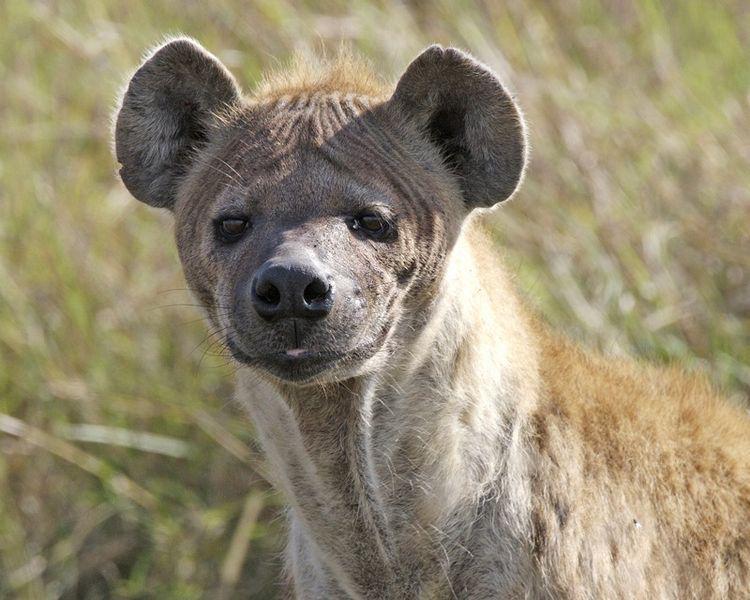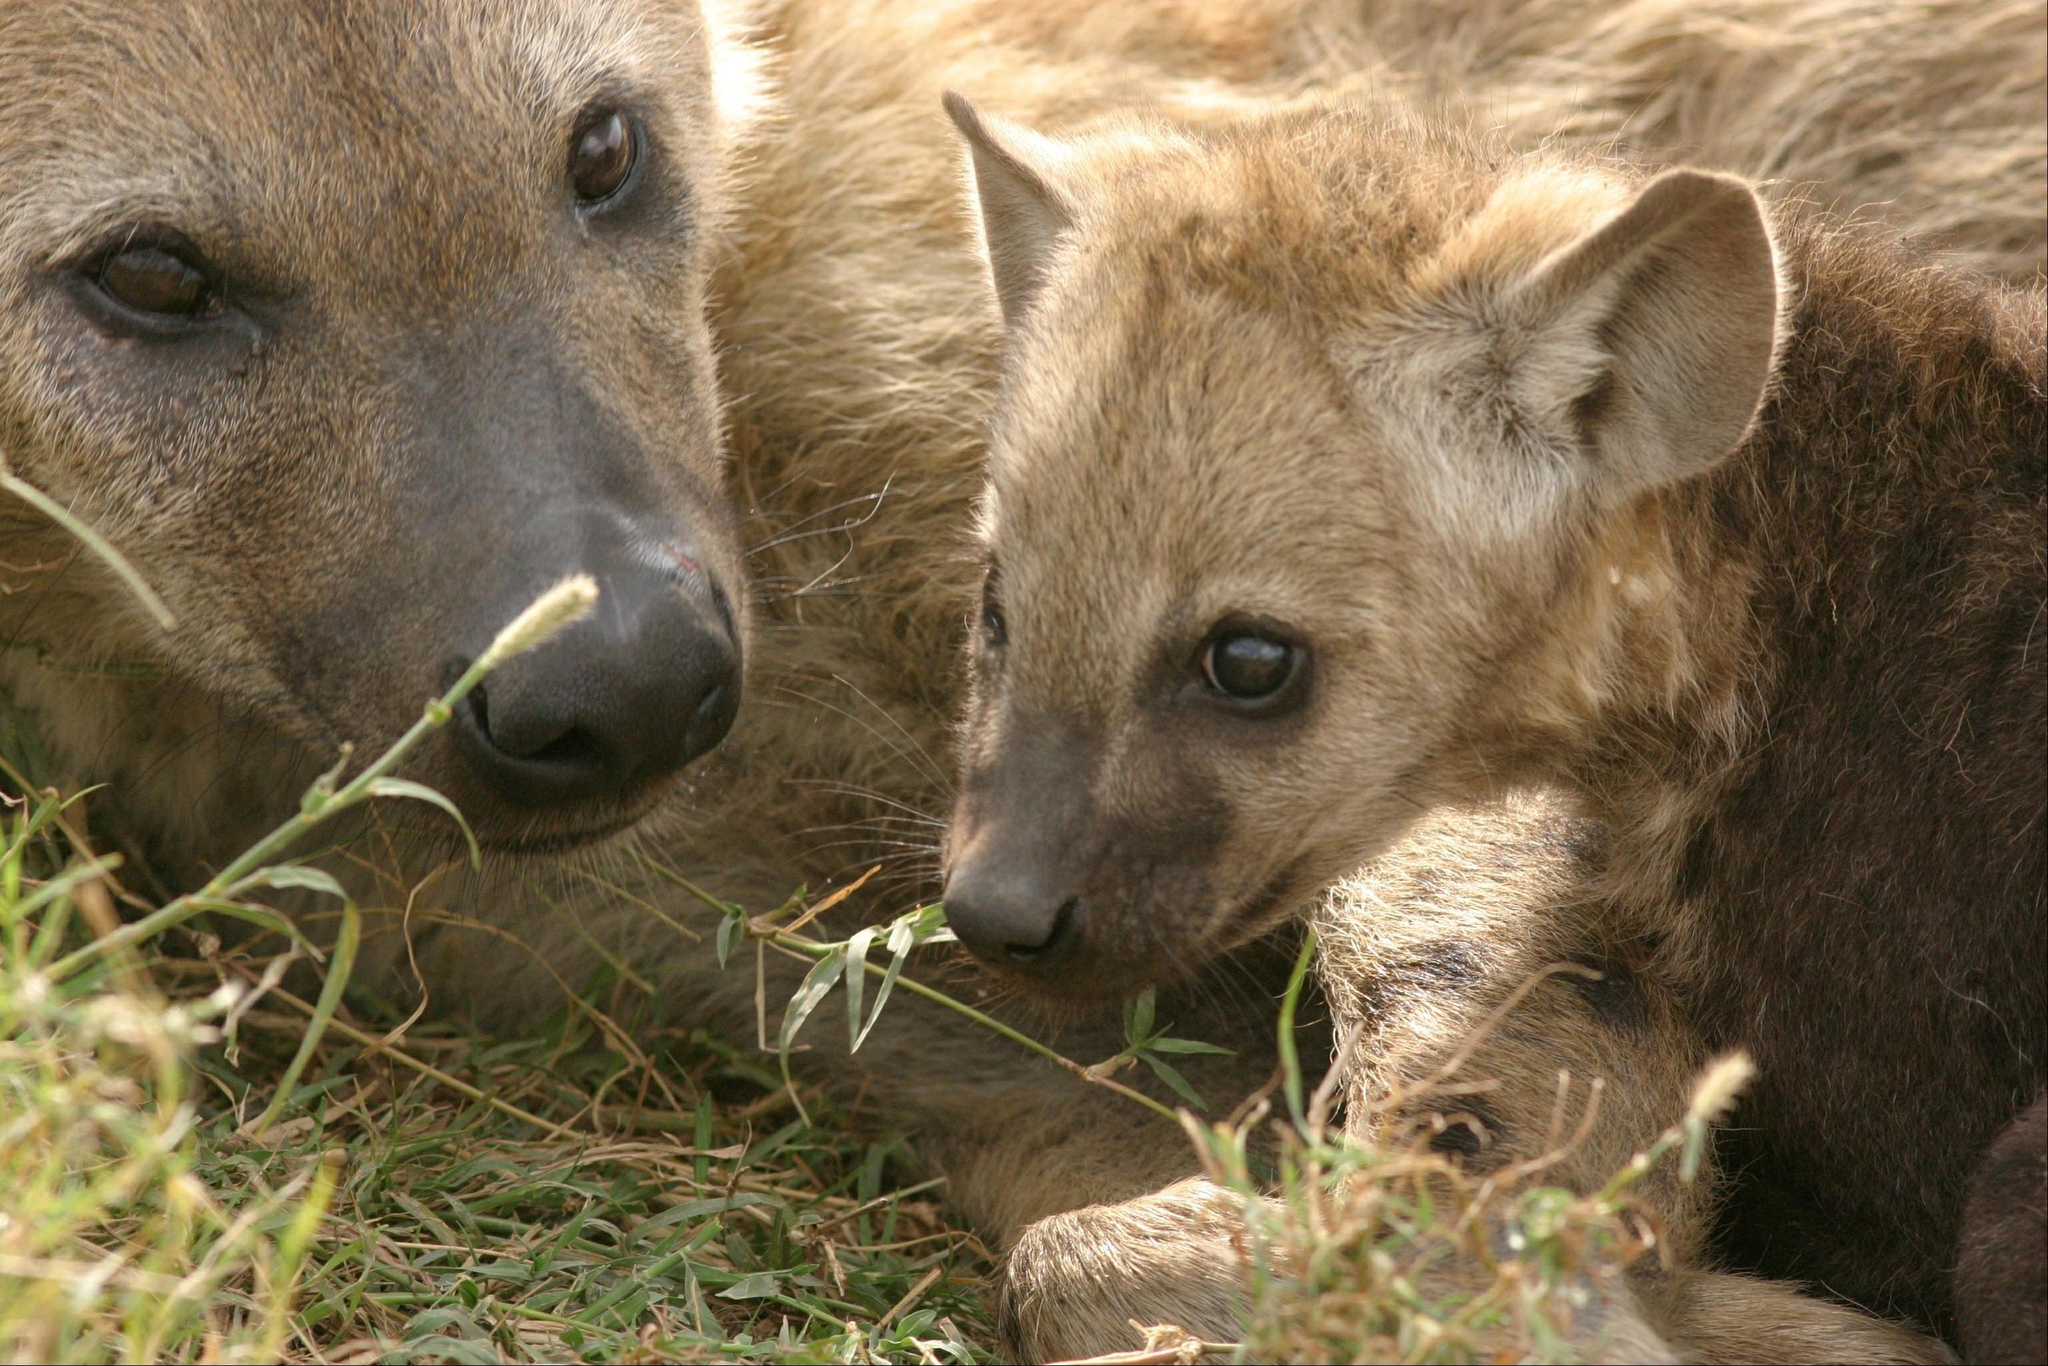The first image is the image on the left, the second image is the image on the right. For the images shown, is this caption "The hyena on the left is a close up of its face at it looks at the camera." true? Answer yes or no. Yes. 